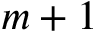<formula> <loc_0><loc_0><loc_500><loc_500>m + 1</formula> 